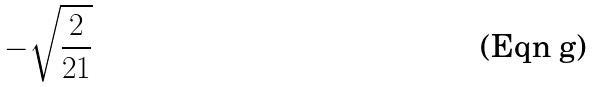Convert formula to latex. <formula><loc_0><loc_0><loc_500><loc_500>- \sqrt { \frac { 2 } { 2 1 } }</formula> 